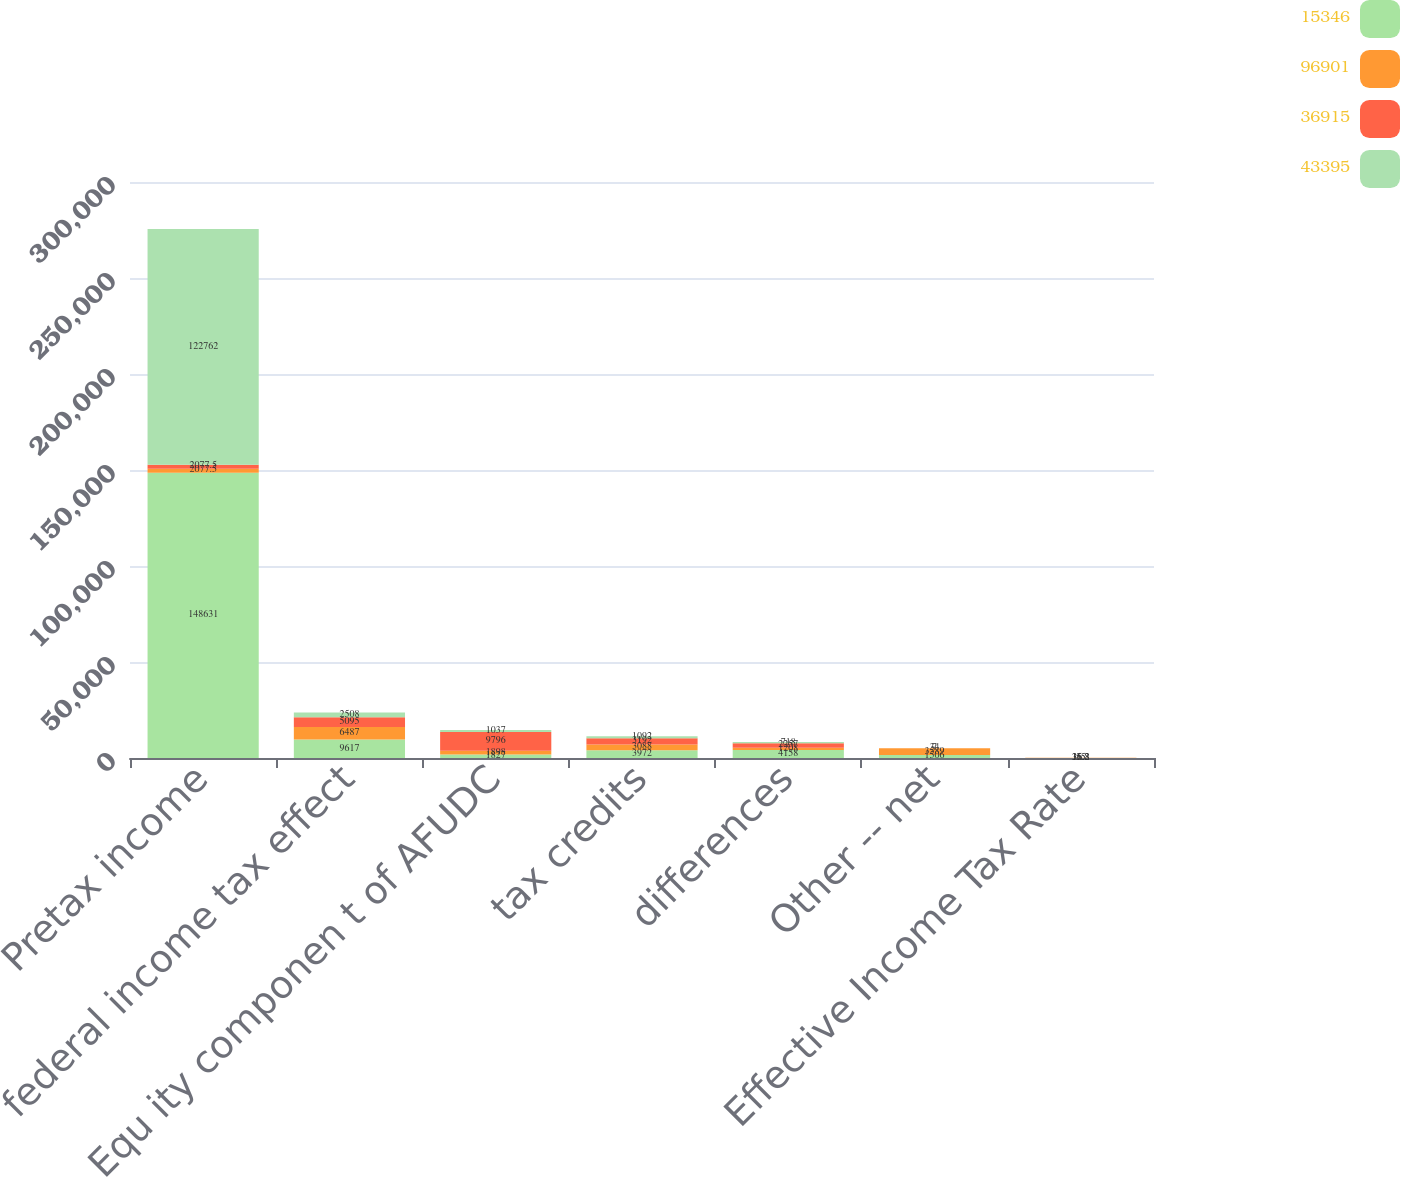Convert chart to OTSL. <chart><loc_0><loc_0><loc_500><loc_500><stacked_bar_chart><ecel><fcel>Pretax income<fcel>federal income tax effect<fcel>Equ ity componen t of AFUDC<fcel>tax credits<fcel>differences<fcel>Other -- net<fcel>Effective Income Tax Rate<nl><fcel>15346<fcel>148631<fcel>9617<fcel>1827<fcel>3972<fcel>4158<fcel>1506<fcel>55<nl><fcel>96901<fcel>2077.5<fcel>6487<fcel>1898<fcel>3088<fcel>1208<fcel>3589<fcel>36.8<nl><fcel>36915<fcel>2077.5<fcel>5095<fcel>9796<fcel>3192<fcel>2257<fcel>34<fcel>16.2<nl><fcel>43395<fcel>122762<fcel>2508<fcel>1037<fcel>1092<fcel>718<fcel>7<fcel>35.3<nl></chart> 